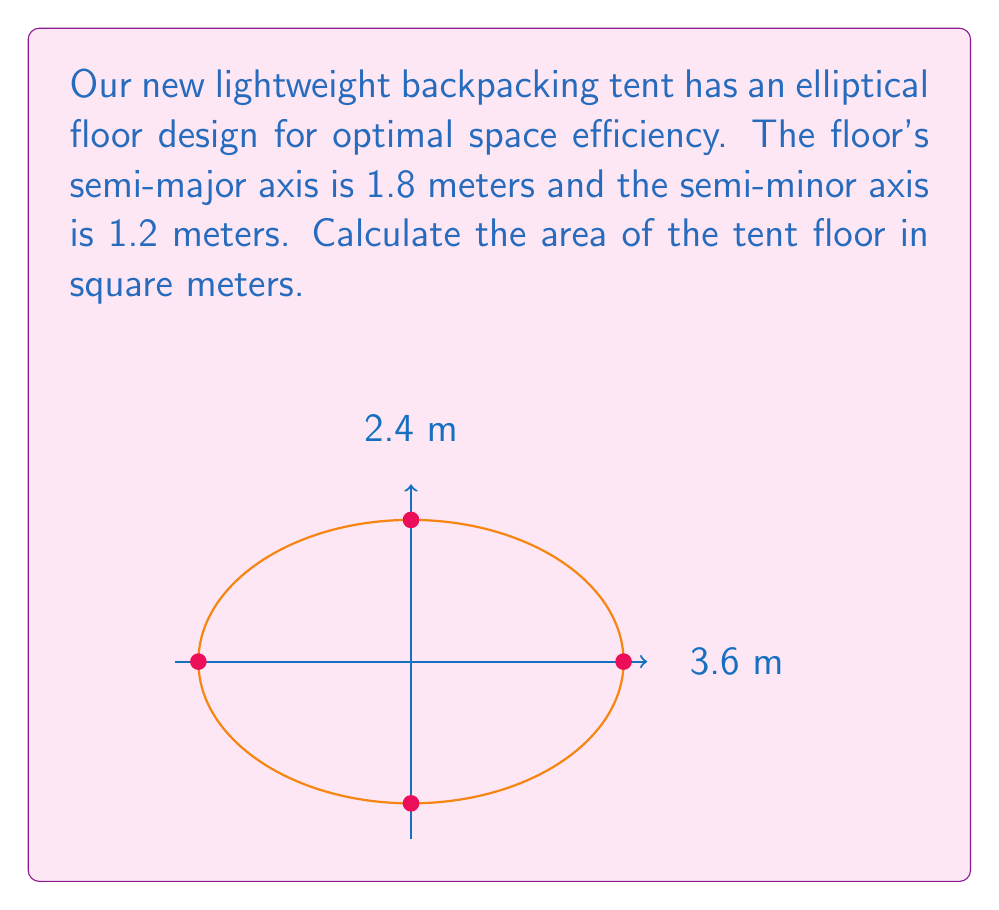Provide a solution to this math problem. To calculate the area of an elliptical tent floor, we use the formula for the area of an ellipse:

$$A = \pi ab$$

Where:
$a$ is the length of the semi-major axis
$b$ is the length of the semi-minor axis

Given:
$a = 1.8$ meters
$b = 1.2$ meters

Step 1: Substitute the values into the formula:
$$A = \pi (1.8)(1.2)$$

Step 2: Multiply the values inside the parentheses:
$$A = \pi (2.16)$$

Step 3: Multiply by $\pi$:
$$A = 6.7858...$$

Step 4: Round to two decimal places:
$$A \approx 6.79 \text{ m}^2$$

Therefore, the area of the tent floor is approximately 6.79 square meters.
Answer: $6.79 \text{ m}^2$ 